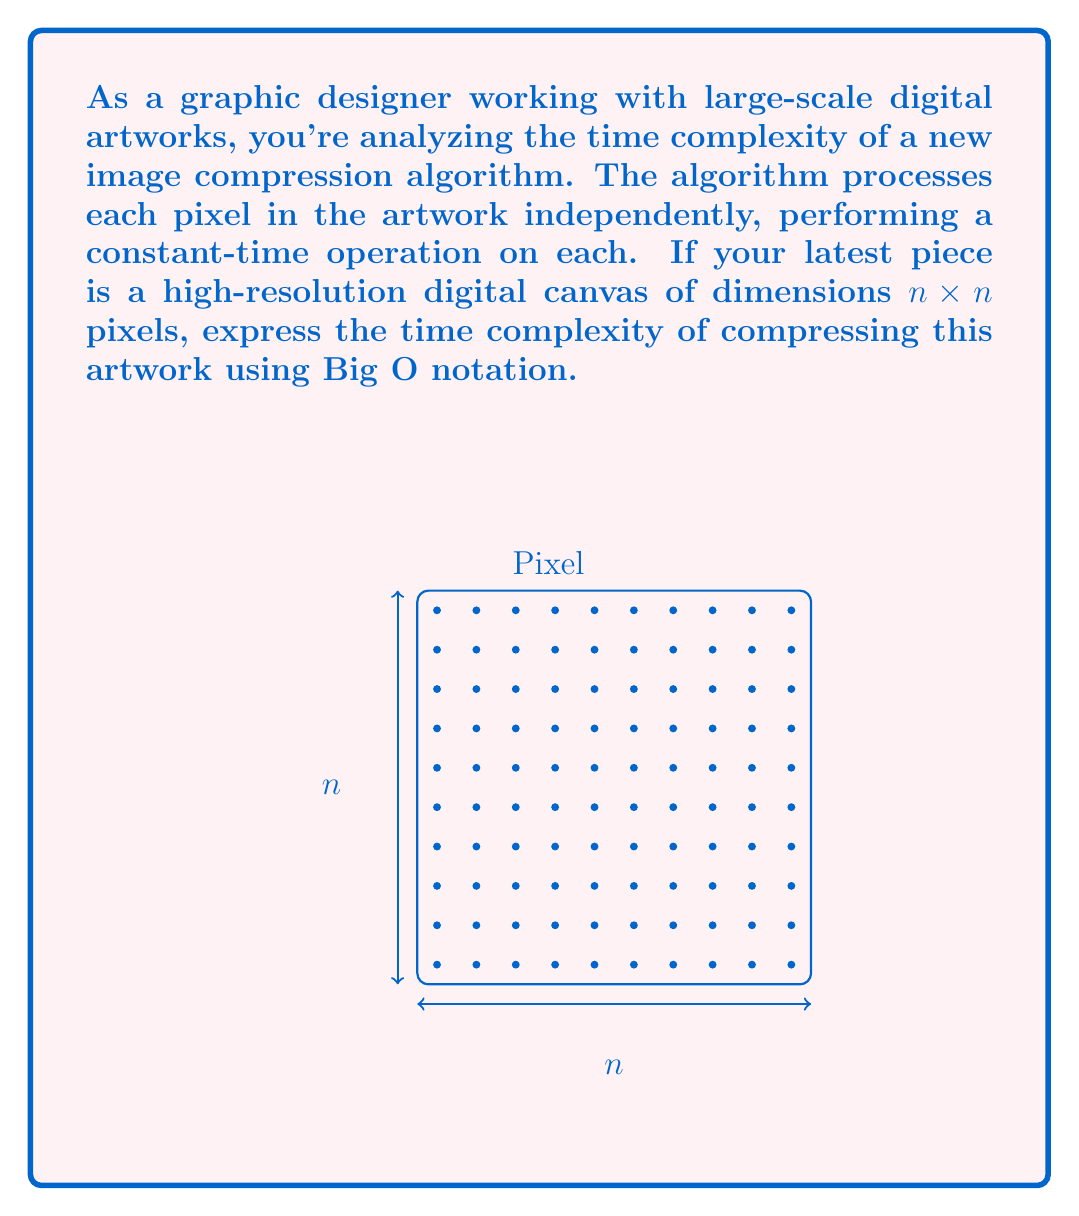Provide a solution to this math problem. Let's approach this step-by-step:

1) First, we need to understand what the algorithm does. It processes each pixel independently with a constant-time operation.

2) The dimensions of the artwork are $n \times n$. This means the total number of pixels in the artwork is $n^2$.

3) For each of these $n^2$ pixels, the algorithm performs a constant-time operation. Let's call the time for this operation $c$.

4) Therefore, the total time taken by the algorithm can be expressed as:

   $T(n) = c \times n^2$

5) In Big O notation, we're interested in the growth rate of the function as $n$ becomes very large. Constants don't affect this growth rate, so we can drop the $c$.

6) This leaves us with a function that grows quadratically with $n$:

   $T(n) = O(n^2)$

7) In computational complexity theory, this is known as quadratic time complexity.

This makes sense intuitively: as we double the width and height of our artwork, we're quadrupling the number of pixels, and thus quadrupling the time taken by the algorithm.
Answer: $O(n^2)$ 